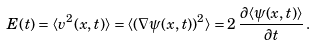<formula> <loc_0><loc_0><loc_500><loc_500>E ( t ) = \langle { v } ^ { 2 } ( { x } , t ) \rangle = \langle ( \nabla { \psi } ( { x } , t ) ) ^ { 2 } \rangle = 2 \, \frac { \partial \langle \psi ( { x } , t ) \rangle } { \partial t } \, .</formula> 